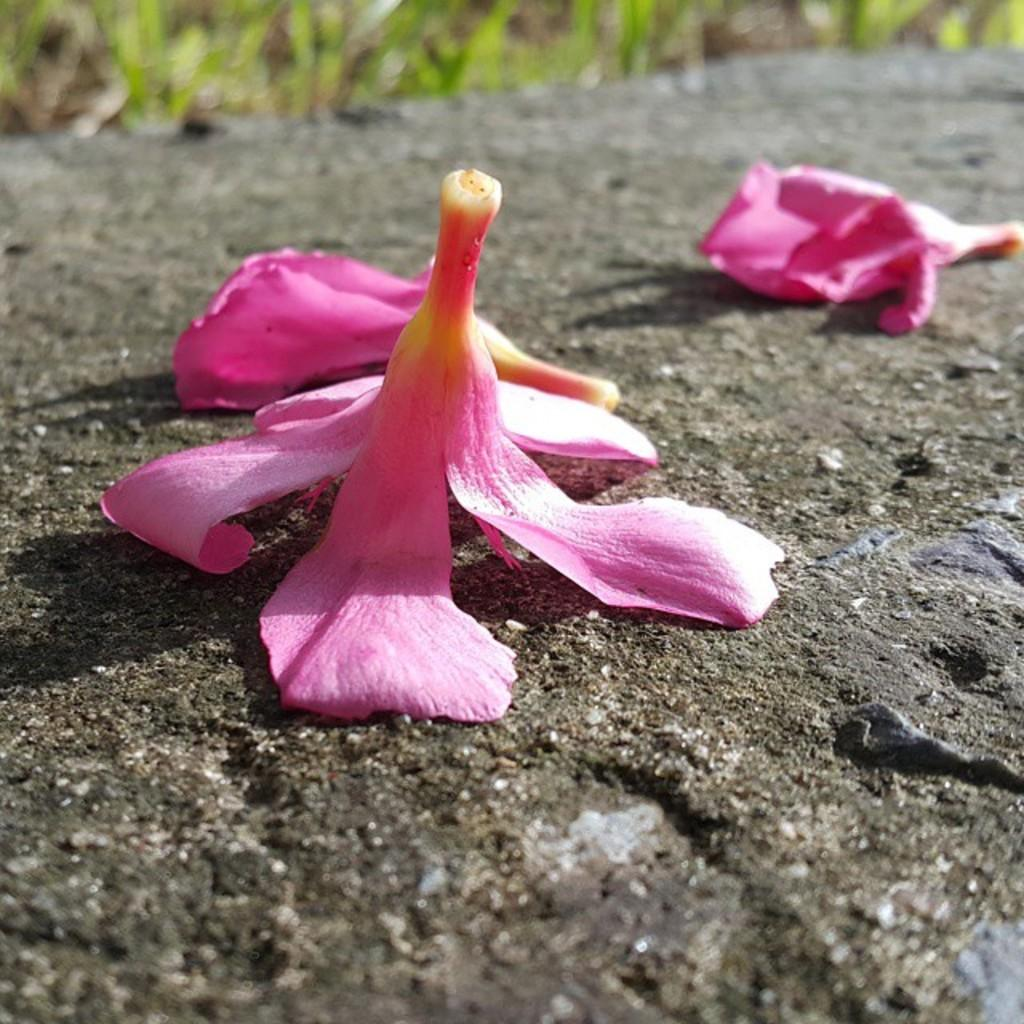What is on the road in the image? There are flowers on the road in the image. What type of vegetation can be seen at the top of the image? Grass is visible at the top of the image. What type of wax can be seen melting on the edge of the image? There is no wax present in the image. What season is depicted in the image, considering the presence of flowers and grass? The image does not provide enough information to determine the season, as flowers and grass can be present in various seasons. 